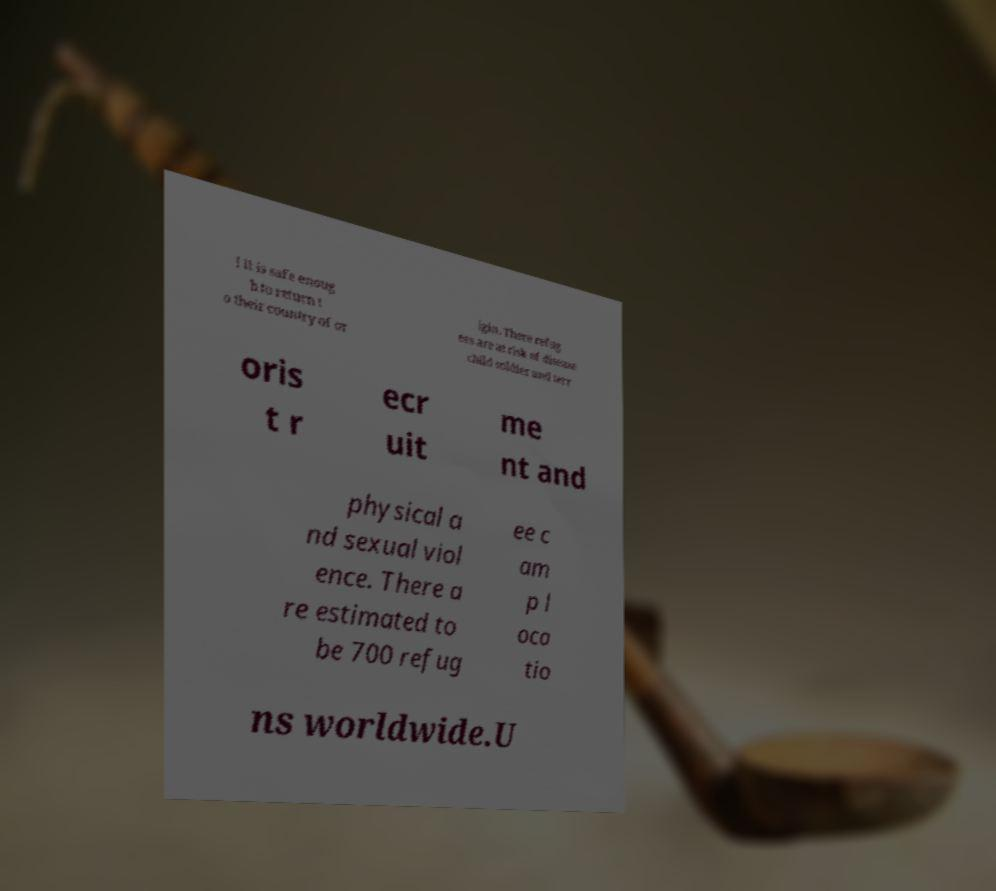Could you extract and type out the text from this image? l it is safe enoug h to return t o their country of or igin. There refug ees are at risk of disease child soldier and terr oris t r ecr uit me nt and physical a nd sexual viol ence. There a re estimated to be 700 refug ee c am p l oca tio ns worldwide.U 